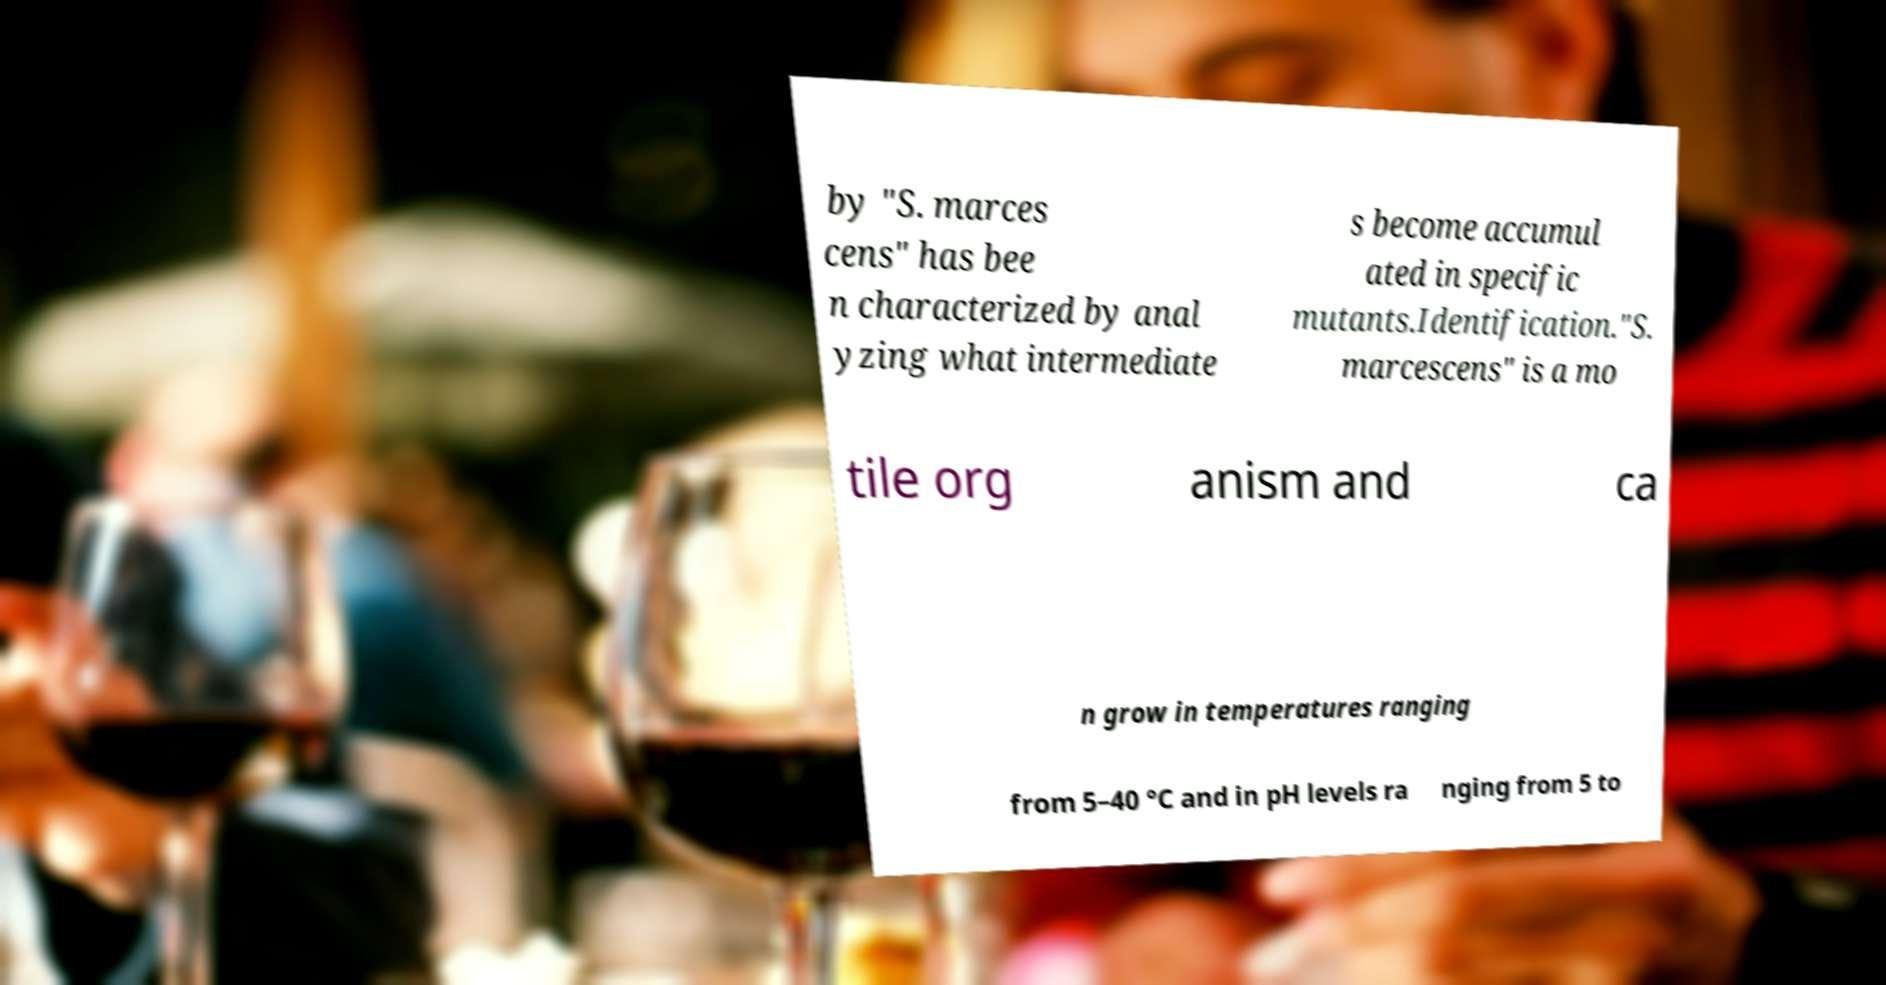Could you assist in decoding the text presented in this image and type it out clearly? by "S. marces cens" has bee n characterized by anal yzing what intermediate s become accumul ated in specific mutants.Identification."S. marcescens" is a mo tile org anism and ca n grow in temperatures ranging from 5–40 °C and in pH levels ra nging from 5 to 